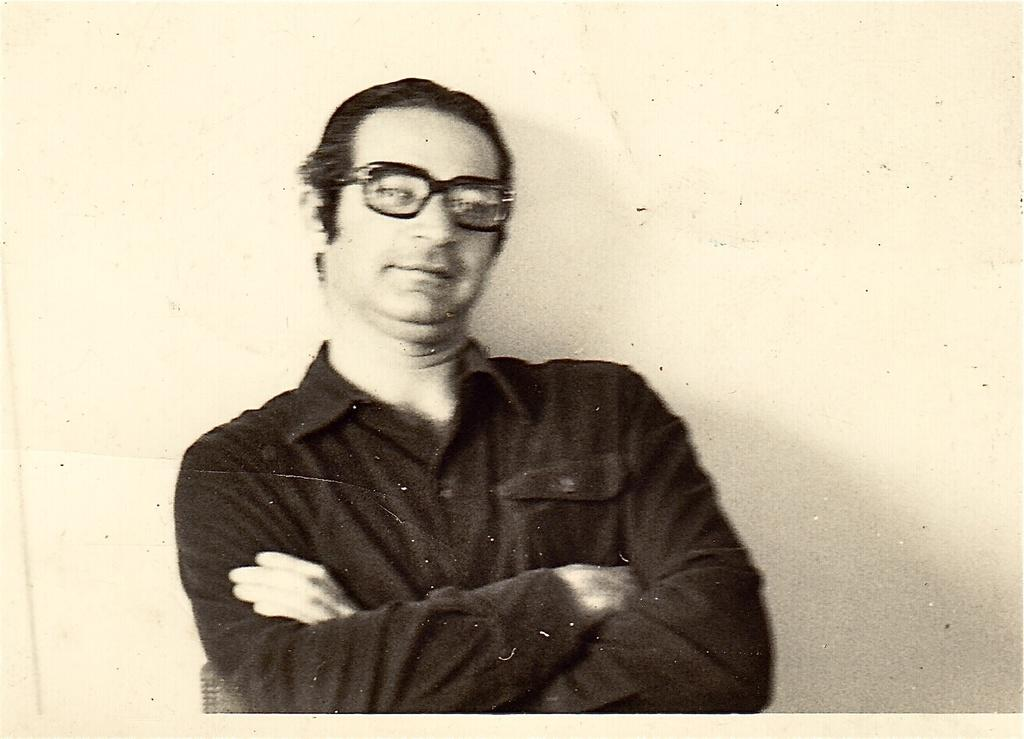What is the main subject of the image? The main subject of the image is a photograph of a person. What is the person in the photograph wearing? The person in the photograph is wearing a shirt. What accessory is the person in the photograph wearing? The person in the photograph is wearing spectacles. What type of gold jewelry is the person wearing in the image? There is no indication of any gold jewelry being worn by the person in the image. How many hands does the person in the photograph have? The image is a photograph, and it does not show the person's hands. --- Facts: 1. There is a car in the image. 2. The car is parked on the street. 3. There are trees in the background of the image. 4. The sky is visible in the background of the image. Absurd Topics: parrot, sand, ocean Conversation: What is the main subject of the image? The main subject of the image is a car. Where is the car located in the image? The car is parked on the street. What can be seen in the background of the image? There are trees and the sky visible in the background of the image. Reasoning: Let's think step by step in order to produce the conversation. We start by identifying the main subject of the image, which is the car. Then, we describe the location of the car, noting that it is parked on the street. Finally, we describe the background of the image, which includes trees and the sky. Absurd Question/Answer: What type of parrot can be seen sitting on the car in the image? There is no parrot present in the image; it features a car parked on the street. What type of sand can be seen surrounding the car in the image? There is no sand present in the image; it features a car parked on the street. 